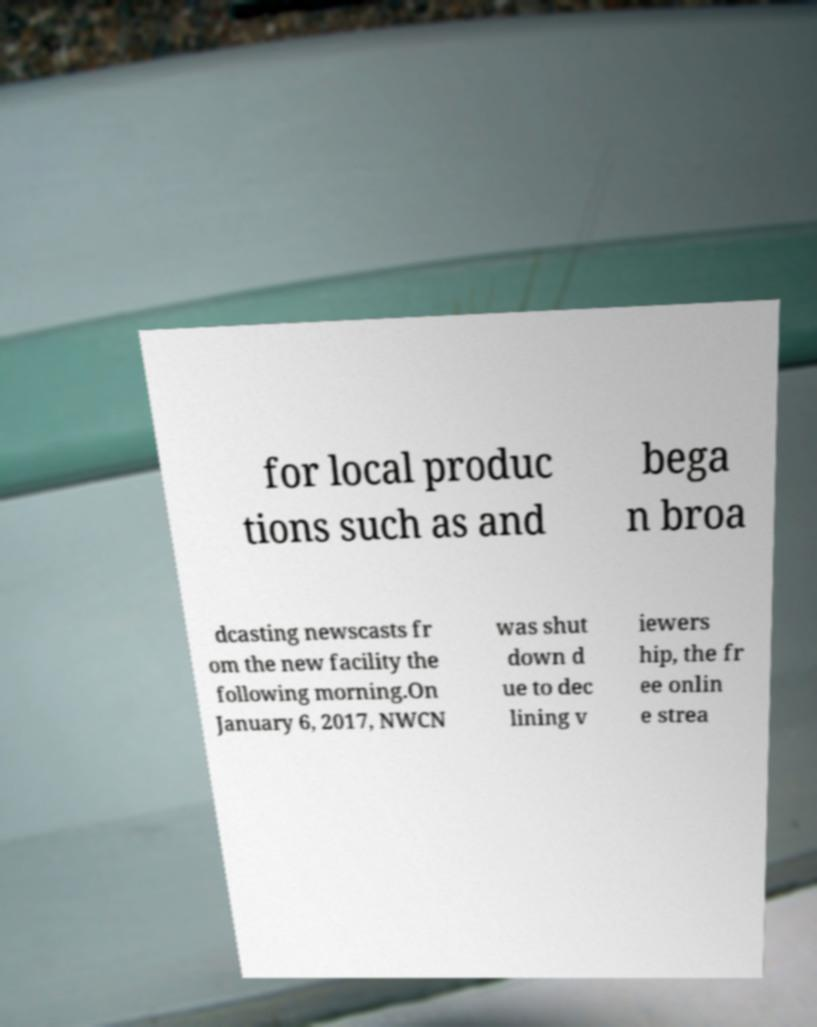Could you assist in decoding the text presented in this image and type it out clearly? for local produc tions such as and bega n broa dcasting newscasts fr om the new facility the following morning.On January 6, 2017, NWCN was shut down d ue to dec lining v iewers hip, the fr ee onlin e strea 